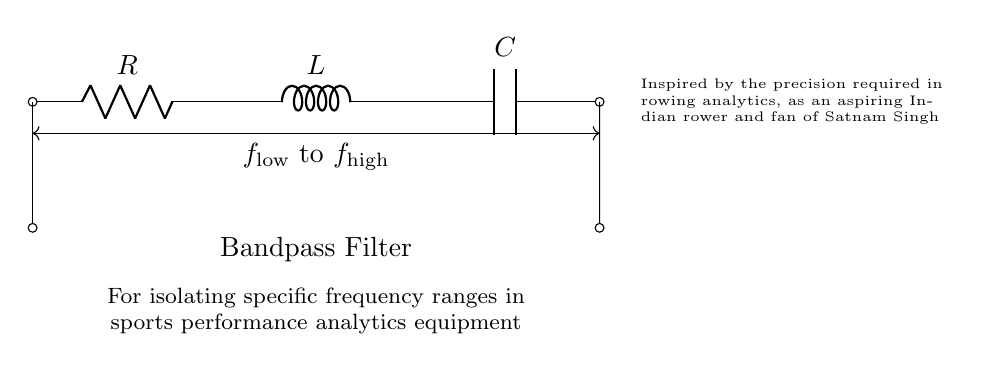What components are present in this circuit? The circuit includes a resistor, an inductor, and a capacitor, which are basic components of an RLC circuit. The labels R, L, and C on the diagram indicate their respective types.
Answer: Resistor, Inductor, Capacitor What is the purpose of this circuit? This circuit is identified as a bandpass filter, which specifically isolates particular frequency ranges, important for analyzing performance metrics in sports. The description below the circuit mentions its application for performance analytics.
Answer: Bandpass filter What type of filter is represented in this circuit? The circuit is a bandpass filter, which allows a specific range of frequencies to pass through while attenuating frequencies outside this range. The labeling of the frequency range as "f low to f high" further supports this.
Answer: Bandpass How does the arrangement of the components affect frequency response? In a bandpass filter, the combination of the resistor, inductor, and capacitor creates a resonance effect at a specific frequency range. The inductor provides high impedance at high frequencies, while the capacitor provides high impedance at low frequencies, thus allowing only the wanted frequencies to pass through.
Answer: Resonance effect What does the notation "f low to f high" signify? The notation represents the frequency range that the bandpass filter effectively isolates. "f low" indicates the lower cutoff frequency and "f high" indicates the upper cutoff frequency, highlighting the range of frequencies the filter is designed to pass.
Answer: Frequency range What is the significance of the RLC circuit in sports performance analytics? The RLC circuit's ability to filter specific frequency ranges allows sports performance analytics equipment to focus on relevant signals, improving the analysis and accuracy of data related to athlete performance, which is crucial for training effectiveness.
Answer: Signal filtering 